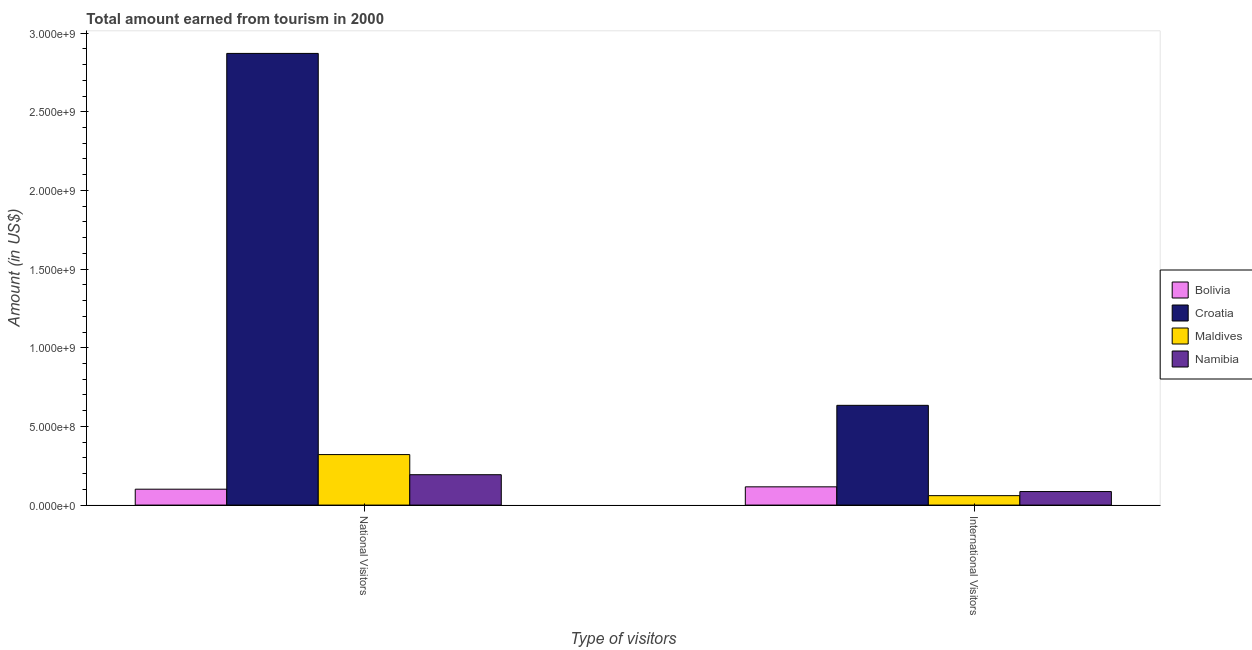Are the number of bars per tick equal to the number of legend labels?
Provide a short and direct response. Yes. How many bars are there on the 2nd tick from the left?
Offer a terse response. 4. How many bars are there on the 1st tick from the right?
Ensure brevity in your answer.  4. What is the label of the 1st group of bars from the left?
Provide a succinct answer. National Visitors. What is the amount earned from national visitors in Bolivia?
Offer a terse response. 1.01e+08. Across all countries, what is the maximum amount earned from national visitors?
Your response must be concise. 2.87e+09. Across all countries, what is the minimum amount earned from international visitors?
Offer a terse response. 6.00e+07. In which country was the amount earned from national visitors maximum?
Your response must be concise. Croatia. What is the total amount earned from international visitors in the graph?
Provide a short and direct response. 8.96e+08. What is the difference between the amount earned from national visitors in Namibia and that in Bolivia?
Offer a terse response. 9.20e+07. What is the difference between the amount earned from international visitors in Namibia and the amount earned from national visitors in Maldives?
Provide a succinct answer. -2.35e+08. What is the average amount earned from national visitors per country?
Your answer should be very brief. 8.72e+08. What is the difference between the amount earned from international visitors and amount earned from national visitors in Croatia?
Provide a short and direct response. -2.24e+09. In how many countries, is the amount earned from international visitors greater than 1100000000 US$?
Your answer should be compact. 0. What is the ratio of the amount earned from international visitors in Bolivia to that in Maldives?
Provide a short and direct response. 1.93. What does the 1st bar from the left in National Visitors represents?
Make the answer very short. Bolivia. What does the 2nd bar from the right in International Visitors represents?
Make the answer very short. Maldives. Are the values on the major ticks of Y-axis written in scientific E-notation?
Your answer should be compact. Yes. Does the graph contain grids?
Your answer should be compact. No. Where does the legend appear in the graph?
Your response must be concise. Center right. What is the title of the graph?
Provide a short and direct response. Total amount earned from tourism in 2000. What is the label or title of the X-axis?
Offer a terse response. Type of visitors. What is the label or title of the Y-axis?
Provide a short and direct response. Amount (in US$). What is the Amount (in US$) of Bolivia in National Visitors?
Your answer should be compact. 1.01e+08. What is the Amount (in US$) in Croatia in National Visitors?
Ensure brevity in your answer.  2.87e+09. What is the Amount (in US$) in Maldives in National Visitors?
Your response must be concise. 3.21e+08. What is the Amount (in US$) of Namibia in National Visitors?
Keep it short and to the point. 1.93e+08. What is the Amount (in US$) of Bolivia in International Visitors?
Ensure brevity in your answer.  1.16e+08. What is the Amount (in US$) of Croatia in International Visitors?
Your answer should be compact. 6.34e+08. What is the Amount (in US$) of Maldives in International Visitors?
Provide a short and direct response. 6.00e+07. What is the Amount (in US$) of Namibia in International Visitors?
Make the answer very short. 8.60e+07. Across all Type of visitors, what is the maximum Amount (in US$) in Bolivia?
Make the answer very short. 1.16e+08. Across all Type of visitors, what is the maximum Amount (in US$) in Croatia?
Your answer should be compact. 2.87e+09. Across all Type of visitors, what is the maximum Amount (in US$) of Maldives?
Your answer should be compact. 3.21e+08. Across all Type of visitors, what is the maximum Amount (in US$) in Namibia?
Make the answer very short. 1.93e+08. Across all Type of visitors, what is the minimum Amount (in US$) in Bolivia?
Keep it short and to the point. 1.01e+08. Across all Type of visitors, what is the minimum Amount (in US$) of Croatia?
Give a very brief answer. 6.34e+08. Across all Type of visitors, what is the minimum Amount (in US$) of Maldives?
Ensure brevity in your answer.  6.00e+07. Across all Type of visitors, what is the minimum Amount (in US$) of Namibia?
Your response must be concise. 8.60e+07. What is the total Amount (in US$) of Bolivia in the graph?
Your answer should be very brief. 2.17e+08. What is the total Amount (in US$) of Croatia in the graph?
Keep it short and to the point. 3.50e+09. What is the total Amount (in US$) in Maldives in the graph?
Ensure brevity in your answer.  3.81e+08. What is the total Amount (in US$) of Namibia in the graph?
Provide a succinct answer. 2.79e+08. What is the difference between the Amount (in US$) in Bolivia in National Visitors and that in International Visitors?
Provide a succinct answer. -1.50e+07. What is the difference between the Amount (in US$) in Croatia in National Visitors and that in International Visitors?
Offer a very short reply. 2.24e+09. What is the difference between the Amount (in US$) in Maldives in National Visitors and that in International Visitors?
Provide a succinct answer. 2.61e+08. What is the difference between the Amount (in US$) of Namibia in National Visitors and that in International Visitors?
Give a very brief answer. 1.07e+08. What is the difference between the Amount (in US$) in Bolivia in National Visitors and the Amount (in US$) in Croatia in International Visitors?
Provide a short and direct response. -5.33e+08. What is the difference between the Amount (in US$) in Bolivia in National Visitors and the Amount (in US$) in Maldives in International Visitors?
Your answer should be compact. 4.10e+07. What is the difference between the Amount (in US$) in Bolivia in National Visitors and the Amount (in US$) in Namibia in International Visitors?
Offer a very short reply. 1.50e+07. What is the difference between the Amount (in US$) of Croatia in National Visitors and the Amount (in US$) of Maldives in International Visitors?
Keep it short and to the point. 2.81e+09. What is the difference between the Amount (in US$) of Croatia in National Visitors and the Amount (in US$) of Namibia in International Visitors?
Offer a very short reply. 2.78e+09. What is the difference between the Amount (in US$) of Maldives in National Visitors and the Amount (in US$) of Namibia in International Visitors?
Provide a short and direct response. 2.35e+08. What is the average Amount (in US$) of Bolivia per Type of visitors?
Your response must be concise. 1.08e+08. What is the average Amount (in US$) in Croatia per Type of visitors?
Ensure brevity in your answer.  1.75e+09. What is the average Amount (in US$) in Maldives per Type of visitors?
Give a very brief answer. 1.90e+08. What is the average Amount (in US$) in Namibia per Type of visitors?
Provide a succinct answer. 1.40e+08. What is the difference between the Amount (in US$) of Bolivia and Amount (in US$) of Croatia in National Visitors?
Make the answer very short. -2.77e+09. What is the difference between the Amount (in US$) in Bolivia and Amount (in US$) in Maldives in National Visitors?
Keep it short and to the point. -2.20e+08. What is the difference between the Amount (in US$) of Bolivia and Amount (in US$) of Namibia in National Visitors?
Offer a very short reply. -9.20e+07. What is the difference between the Amount (in US$) in Croatia and Amount (in US$) in Maldives in National Visitors?
Provide a short and direct response. 2.55e+09. What is the difference between the Amount (in US$) of Croatia and Amount (in US$) of Namibia in National Visitors?
Your response must be concise. 2.68e+09. What is the difference between the Amount (in US$) of Maldives and Amount (in US$) of Namibia in National Visitors?
Offer a terse response. 1.28e+08. What is the difference between the Amount (in US$) in Bolivia and Amount (in US$) in Croatia in International Visitors?
Your answer should be very brief. -5.18e+08. What is the difference between the Amount (in US$) in Bolivia and Amount (in US$) in Maldives in International Visitors?
Provide a short and direct response. 5.60e+07. What is the difference between the Amount (in US$) in Bolivia and Amount (in US$) in Namibia in International Visitors?
Offer a terse response. 3.00e+07. What is the difference between the Amount (in US$) in Croatia and Amount (in US$) in Maldives in International Visitors?
Give a very brief answer. 5.74e+08. What is the difference between the Amount (in US$) of Croatia and Amount (in US$) of Namibia in International Visitors?
Offer a terse response. 5.48e+08. What is the difference between the Amount (in US$) of Maldives and Amount (in US$) of Namibia in International Visitors?
Your answer should be compact. -2.60e+07. What is the ratio of the Amount (in US$) of Bolivia in National Visitors to that in International Visitors?
Ensure brevity in your answer.  0.87. What is the ratio of the Amount (in US$) of Croatia in National Visitors to that in International Visitors?
Provide a succinct answer. 4.53. What is the ratio of the Amount (in US$) in Maldives in National Visitors to that in International Visitors?
Your response must be concise. 5.35. What is the ratio of the Amount (in US$) in Namibia in National Visitors to that in International Visitors?
Offer a very short reply. 2.24. What is the difference between the highest and the second highest Amount (in US$) of Bolivia?
Your answer should be very brief. 1.50e+07. What is the difference between the highest and the second highest Amount (in US$) of Croatia?
Ensure brevity in your answer.  2.24e+09. What is the difference between the highest and the second highest Amount (in US$) of Maldives?
Give a very brief answer. 2.61e+08. What is the difference between the highest and the second highest Amount (in US$) of Namibia?
Your answer should be very brief. 1.07e+08. What is the difference between the highest and the lowest Amount (in US$) of Bolivia?
Keep it short and to the point. 1.50e+07. What is the difference between the highest and the lowest Amount (in US$) in Croatia?
Your answer should be very brief. 2.24e+09. What is the difference between the highest and the lowest Amount (in US$) of Maldives?
Make the answer very short. 2.61e+08. What is the difference between the highest and the lowest Amount (in US$) of Namibia?
Your answer should be compact. 1.07e+08. 